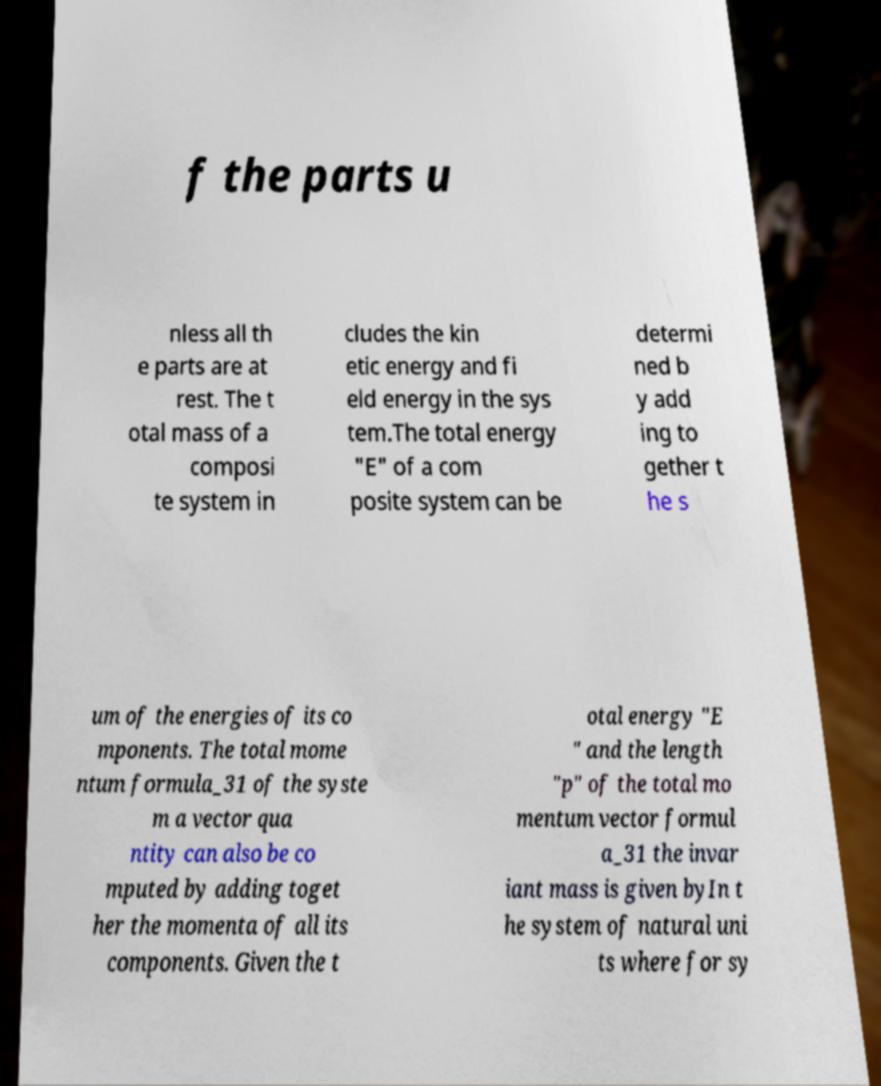Can you accurately transcribe the text from the provided image for me? f the parts u nless all th e parts are at rest. The t otal mass of a composi te system in cludes the kin etic energy and fi eld energy in the sys tem.The total energy "E" of a com posite system can be determi ned b y add ing to gether t he s um of the energies of its co mponents. The total mome ntum formula_31 of the syste m a vector qua ntity can also be co mputed by adding toget her the momenta of all its components. Given the t otal energy "E " and the length "p" of the total mo mentum vector formul a_31 the invar iant mass is given byIn t he system of natural uni ts where for sy 